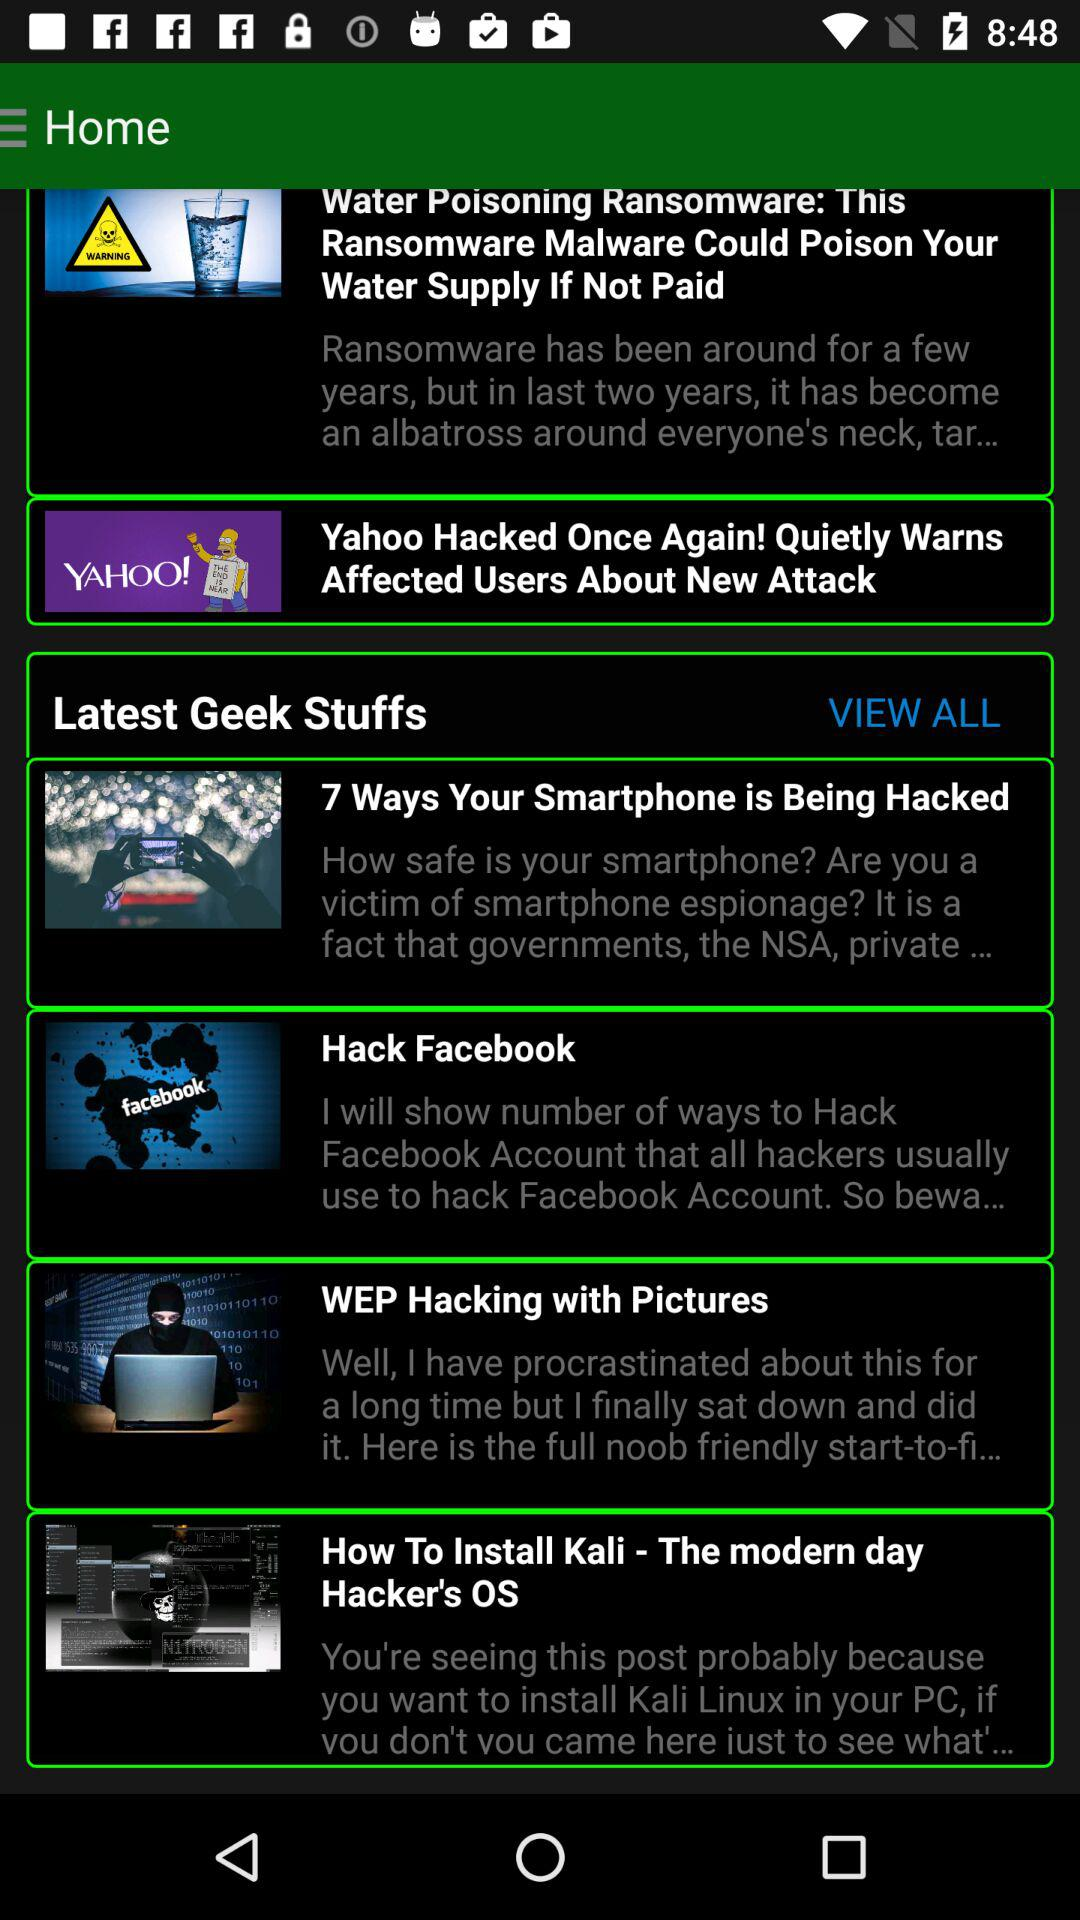What are the topics in "Latest Geek Stuffs"? The topics are "7 Ways Your Smartphone is Being Hacked", "Hack Facebook", "WEP Hacking with Pictures" and "How To Install Kali - The modern day Hacker's OS". 